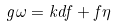<formula> <loc_0><loc_0><loc_500><loc_500>g \omega = k d f + f \eta</formula> 